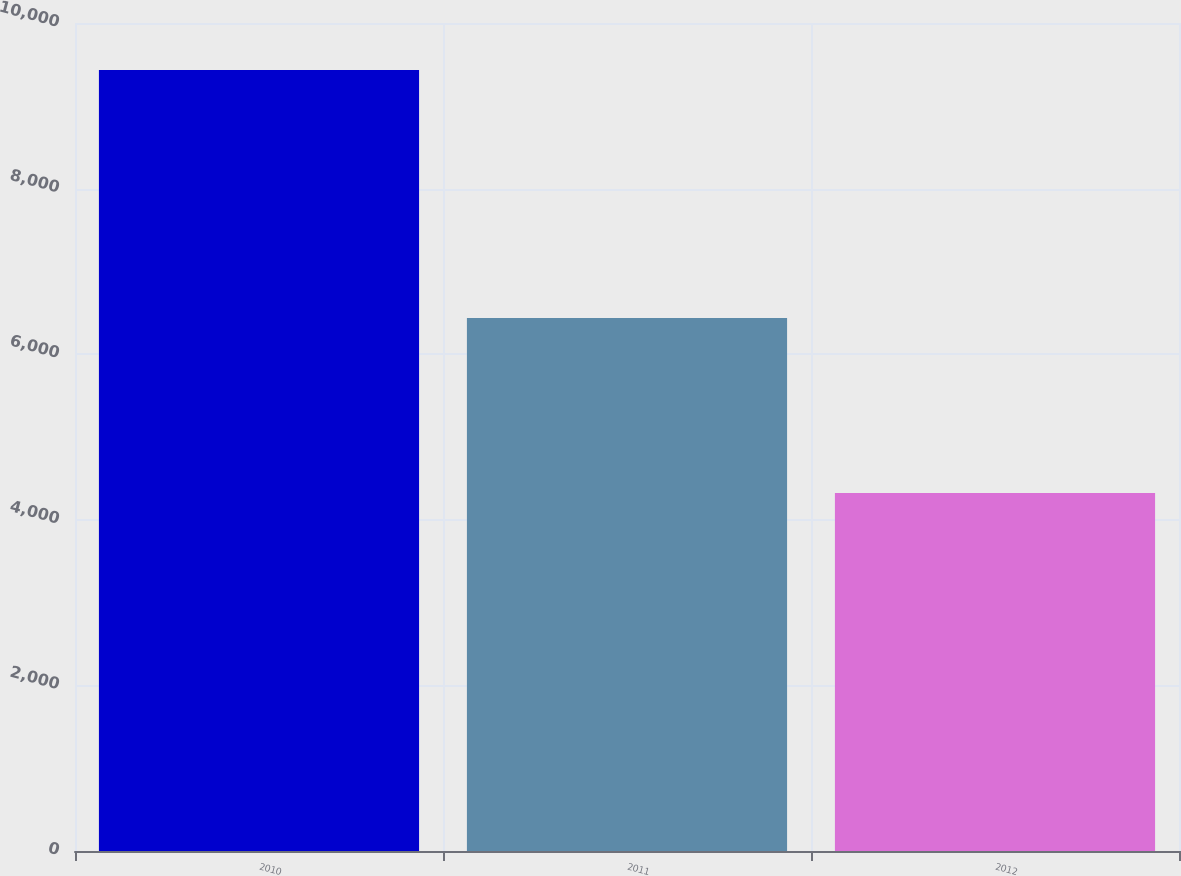<chart> <loc_0><loc_0><loc_500><loc_500><bar_chart><fcel>2010<fcel>2011<fcel>2012<nl><fcel>9433<fcel>6436<fcel>4325<nl></chart> 